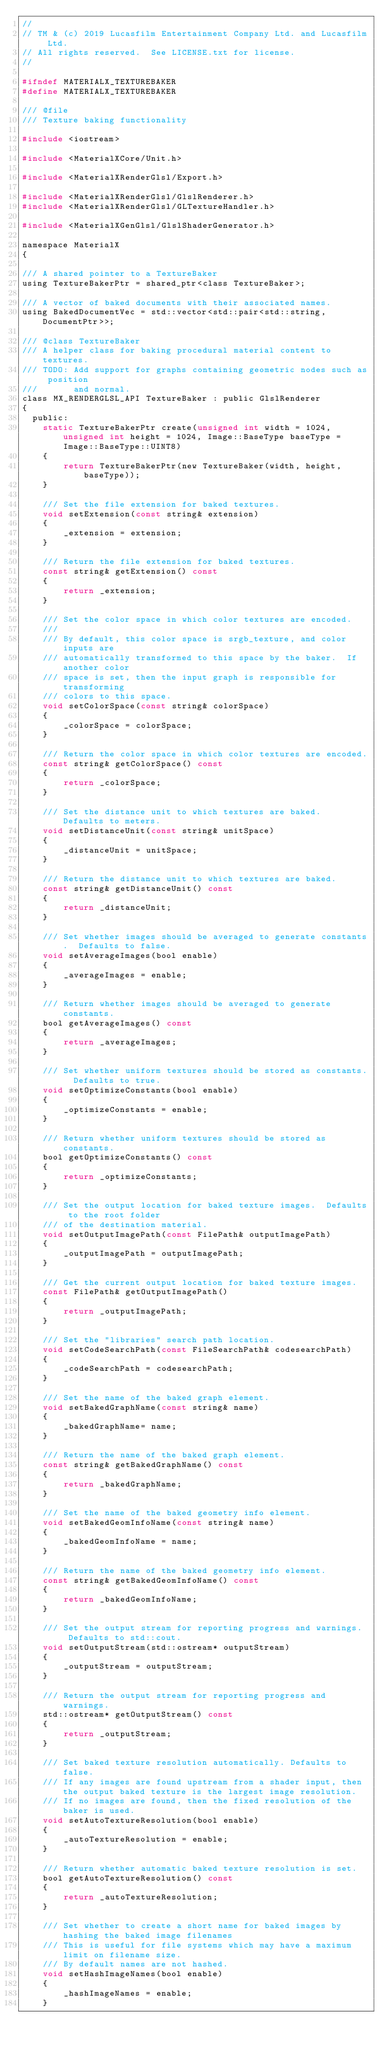<code> <loc_0><loc_0><loc_500><loc_500><_C_>//
// TM & (c) 2019 Lucasfilm Entertainment Company Ltd. and Lucasfilm Ltd.
// All rights reserved.  See LICENSE.txt for license.
//

#ifndef MATERIALX_TEXTUREBAKER
#define MATERIALX_TEXTUREBAKER

/// @file
/// Texture baking functionality

#include <iostream>

#include <MaterialXCore/Unit.h>

#include <MaterialXRenderGlsl/Export.h>

#include <MaterialXRenderGlsl/GlslRenderer.h>
#include <MaterialXRenderGlsl/GLTextureHandler.h>

#include <MaterialXGenGlsl/GlslShaderGenerator.h>

namespace MaterialX
{

/// A shared pointer to a TextureBaker
using TextureBakerPtr = shared_ptr<class TextureBaker>;

/// A vector of baked documents with their associated names.
using BakedDocumentVec = std::vector<std::pair<std::string, DocumentPtr>>;

/// @class TextureBaker
/// A helper class for baking procedural material content to textures.
/// TODO: Add support for graphs containing geometric nodes such as position
///       and normal.
class MX_RENDERGLSL_API TextureBaker : public GlslRenderer
{
  public:
    static TextureBakerPtr create(unsigned int width = 1024, unsigned int height = 1024, Image::BaseType baseType = Image::BaseType::UINT8)
    {
        return TextureBakerPtr(new TextureBaker(width, height, baseType));
    }

    /// Set the file extension for baked textures.
    void setExtension(const string& extension)
    {
        _extension = extension;
    }

    /// Return the file extension for baked textures.
    const string& getExtension() const
    {
        return _extension;
    }

    /// Set the color space in which color textures are encoded.
    ///
    /// By default, this color space is srgb_texture, and color inputs are
    /// automatically transformed to this space by the baker.  If another color
    /// space is set, then the input graph is responsible for transforming
    /// colors to this space.
    void setColorSpace(const string& colorSpace)
    {
        _colorSpace = colorSpace;
    }

    /// Return the color space in which color textures are encoded.
    const string& getColorSpace() const
    {
        return _colorSpace;
    }

    /// Set the distance unit to which textures are baked.  Defaults to meters.
    void setDistanceUnit(const string& unitSpace)
    {
        _distanceUnit = unitSpace;
    }

    /// Return the distance unit to which textures are baked.
    const string& getDistanceUnit() const
    {
        return _distanceUnit;
    }

    /// Set whether images should be averaged to generate constants.  Defaults to false.
    void setAverageImages(bool enable)
    {
        _averageImages = enable;
    }

    /// Return whether images should be averaged to generate constants.
    bool getAverageImages() const
    {
        return _averageImages;
    }

    /// Set whether uniform textures should be stored as constants.  Defaults to true.
    void setOptimizeConstants(bool enable)
    {
        _optimizeConstants = enable;
    }

    /// Return whether uniform textures should be stored as constants.
    bool getOptimizeConstants() const
    {
        return _optimizeConstants;
    }

    /// Set the output location for baked texture images.  Defaults to the root folder
    /// of the destination material.
    void setOutputImagePath(const FilePath& outputImagePath)
    {
        _outputImagePath = outputImagePath;
    }

    /// Get the current output location for baked texture images.
    const FilePath& getOutputImagePath()
    {
        return _outputImagePath;
    }

    /// Set the "libraries" search path location.
    void setCodeSearchPath(const FileSearchPath& codesearchPath)
    {
        _codeSearchPath = codesearchPath;
    }

    /// Set the name of the baked graph element.
    void setBakedGraphName(const string& name)
    {
        _bakedGraphName= name;
    }

    /// Return the name of the baked graph element.
    const string& getBakedGraphName() const
    {
        return _bakedGraphName;
    }

    /// Set the name of the baked geometry info element.
    void setBakedGeomInfoName(const string& name)
    {
        _bakedGeomInfoName = name;
    }

    /// Return the name of the baked geometry info element.
    const string& getBakedGeomInfoName() const
    {
        return _bakedGeomInfoName;
    }

    /// Set the output stream for reporting progress and warnings.  Defaults to std::cout.
    void setOutputStream(std::ostream* outputStream)
    {
        _outputStream = outputStream;
    }

    /// Return the output stream for reporting progress and warnings.
    std::ostream* getOutputStream() const
    {
        return _outputStream;
    }

    /// Set baked texture resolution automatically. Defaults to false.
    /// If any images are found upstream from a shader input, then the output baked texture is the largest image resolution. 
    /// If no images are found, then the fixed resolution of the baker is used.
    void setAutoTextureResolution(bool enable)
    {
        _autoTextureResolution = enable;
    }

    /// Return whether automatic baked texture resolution is set.
    bool getAutoTextureResolution() const
    {
        return _autoTextureResolution;
    }

    /// Set whether to create a short name for baked images by hashing the baked image filenames
    /// This is useful for file systems which may have a maximum limit on filename size.
    /// By default names are not hashed.
    void setHashImageNames(bool enable)
    {
        _hashImageNames = enable;
    }
</code> 